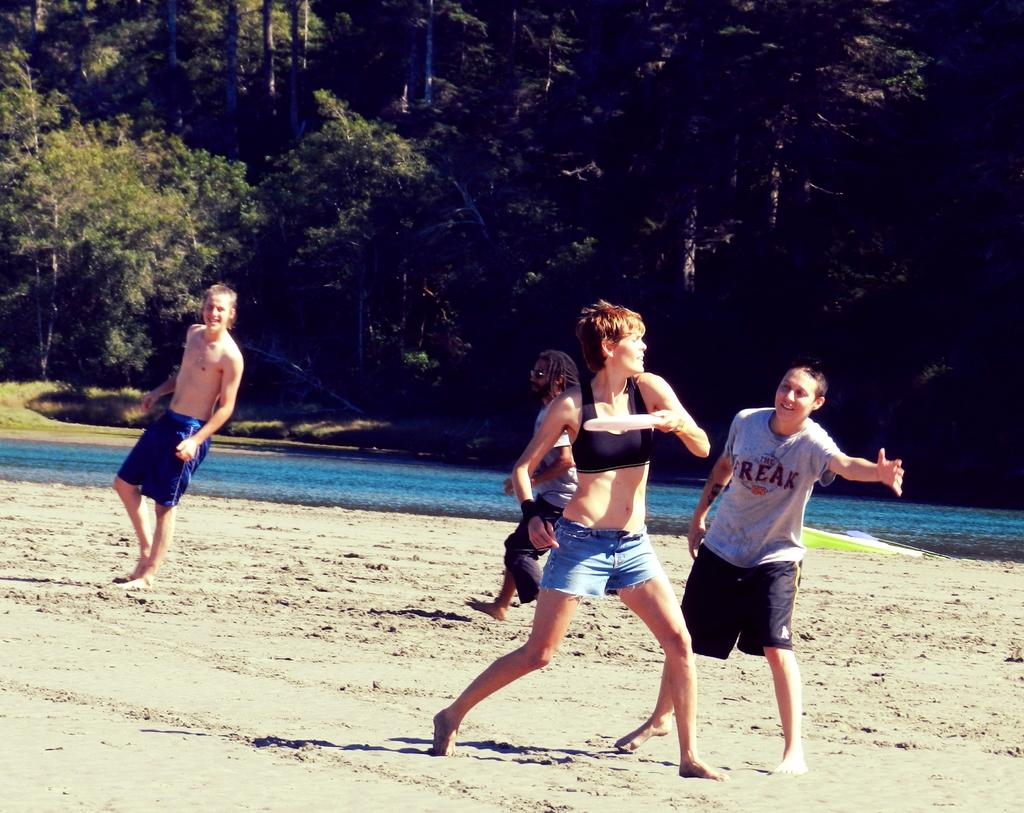How many people are present in the image? There are four people in the image. Can you describe the position of the woman in the image? The woman is in the middle of the image. What is the woman holding in the image? The woman is holding a disk. What can be seen in the background of the image? There is water and trees visible in the background of the image. What type of animal can be seen on the shelf in the image? There is no shelf or animal present in the image. 